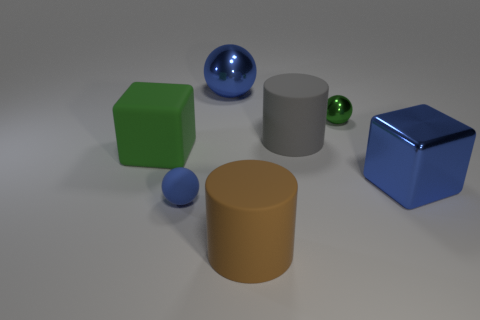Add 1 big green blocks. How many objects exist? 8 Subtract all cylinders. How many objects are left? 5 Add 5 cubes. How many cubes exist? 7 Subtract 0 cyan cubes. How many objects are left? 7 Subtract all green matte objects. Subtract all small metal balls. How many objects are left? 5 Add 5 big brown matte cylinders. How many big brown matte cylinders are left? 6 